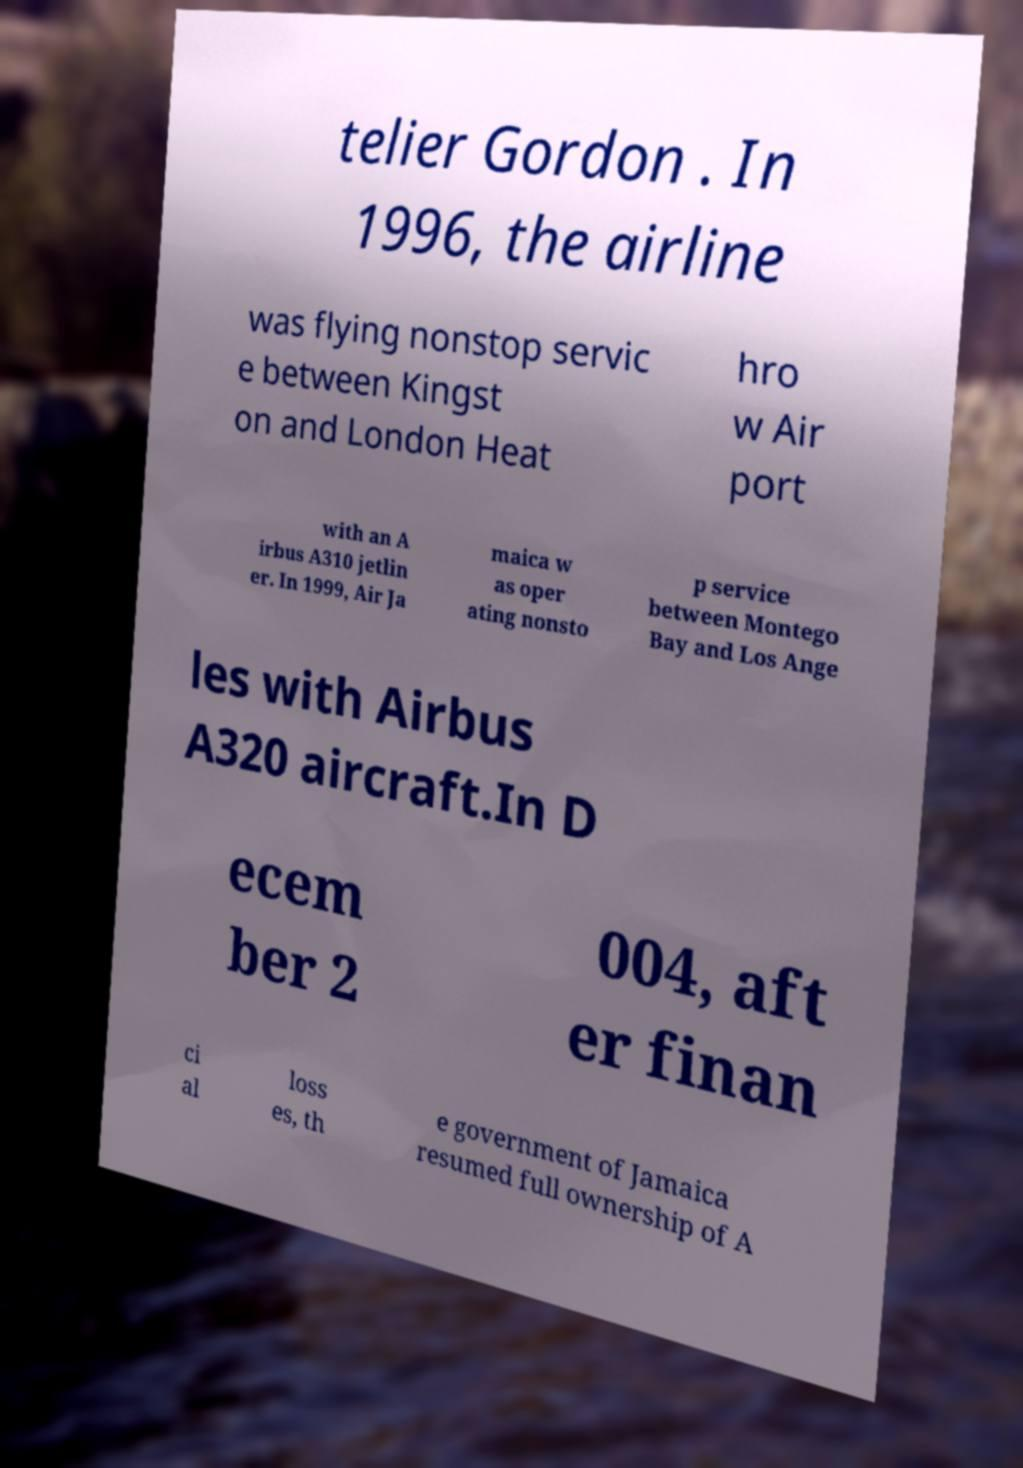Can you read and provide the text displayed in the image?This photo seems to have some interesting text. Can you extract and type it out for me? telier Gordon . In 1996, the airline was flying nonstop servic e between Kingst on and London Heat hro w Air port with an A irbus A310 jetlin er. In 1999, Air Ja maica w as oper ating nonsto p service between Montego Bay and Los Ange les with Airbus A320 aircraft.In D ecem ber 2 004, aft er finan ci al loss es, th e government of Jamaica resumed full ownership of A 